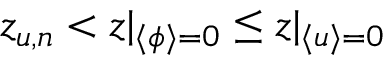Convert formula to latex. <formula><loc_0><loc_0><loc_500><loc_500>z _ { u , n } < z | _ { \langle \phi \rangle = 0 } \leq z | _ { \langle u \rangle = 0 }</formula> 